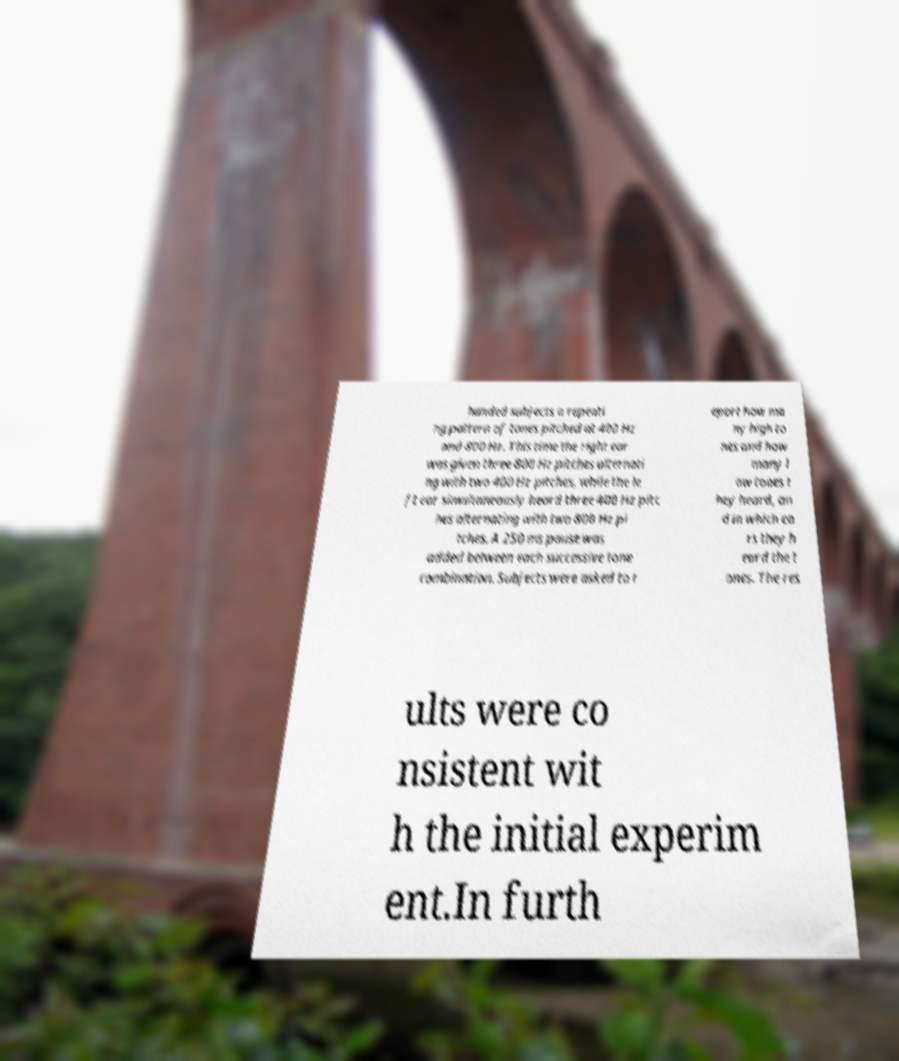Could you assist in decoding the text presented in this image and type it out clearly? handed subjects a repeati ng pattern of tones pitched at 400 Hz and 800 Hz. This time the right ear was given three 800 Hz pitches alternati ng with two 400 Hz pitches, while the le ft ear simultaneously heard three 400 Hz pitc hes alternating with two 800 Hz pi tches. A 250 ms pause was added between each successive tone combination. Subjects were asked to r eport how ma ny high to nes and how many l ow tones t hey heard, an d in which ea rs they h eard the t ones. The res ults were co nsistent wit h the initial experim ent.In furth 